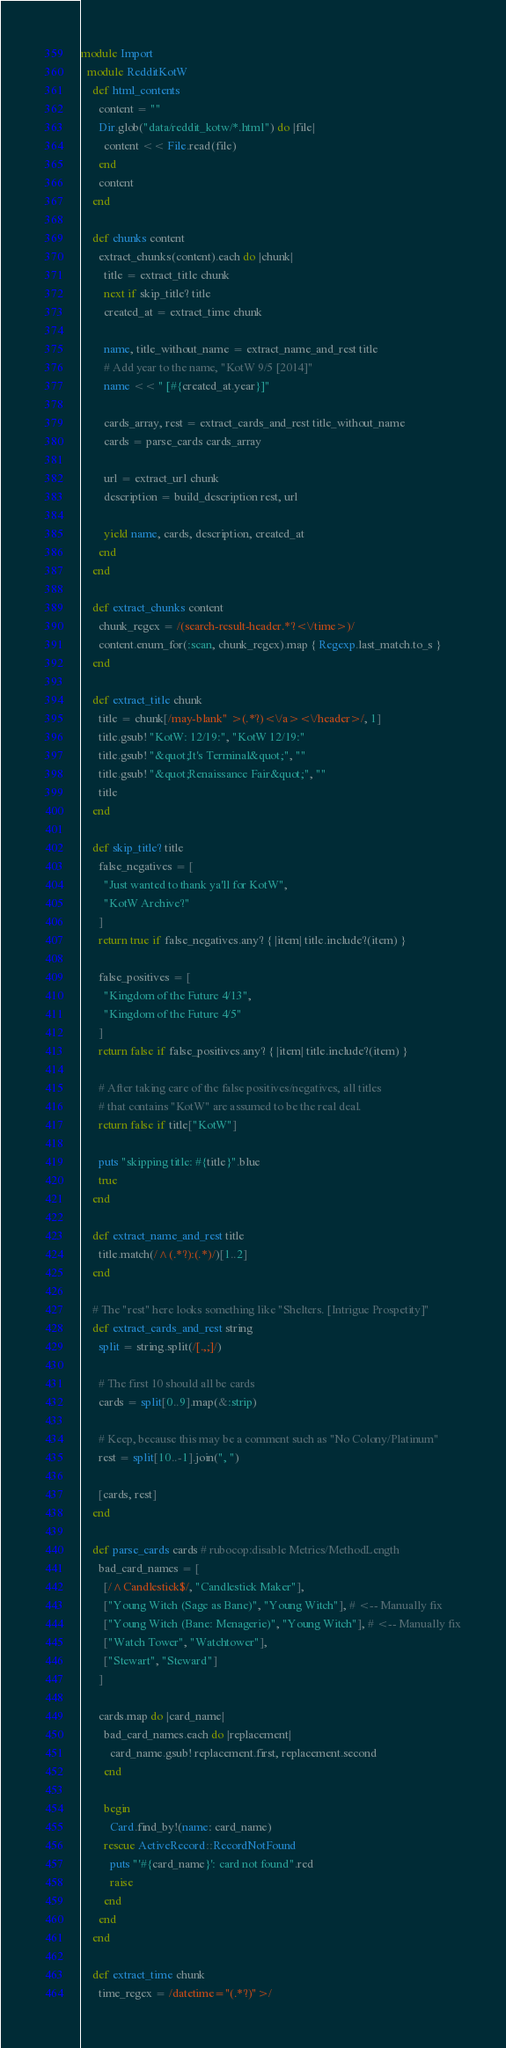Convert code to text. <code><loc_0><loc_0><loc_500><loc_500><_Ruby_>module Import
  module RedditKotW
    def html_contents
      content = ""
      Dir.glob("data/reddit_kotw/*.html") do |file|
        content << File.read(file)
      end
      content
    end

    def chunks content
      extract_chunks(content).each do |chunk|
        title = extract_title chunk
        next if skip_title? title
        created_at = extract_time chunk

        name, title_without_name = extract_name_and_rest title
        # Add year to the name, "KotW 9/5 [2014]"
        name << " [#{created_at.year}]"

        cards_array, rest = extract_cards_and_rest title_without_name
        cards = parse_cards cards_array

        url = extract_url chunk
        description = build_description rest, url

        yield name, cards, description, created_at
      end
    end

    def extract_chunks content
      chunk_regex = /(search-result-header.*?<\/time>)/
      content.enum_for(:scan, chunk_regex).map { Regexp.last_match.to_s }
    end

    def extract_title chunk
      title = chunk[/may-blank" >(.*?)<\/a><\/header>/, 1]
      title.gsub! "KotW: 12/19:", "KotW 12/19:"
      title.gsub! "&quot;It's Terminal&quot;", ""
      title.gsub! "&quot;Renaissance Fair&quot;", ""
      title
    end

    def skip_title? title
      false_negatives = [
        "Just wanted to thank ya'll for KotW",
        "KotW Archive?"
      ]
      return true if false_negatives.any? { |item| title.include?(item) }

      false_positives = [
        "Kingdom of the Future 4/13",
        "Kingdom of the Future 4/5"
      ]
      return false if false_positives.any? { |item| title.include?(item) }

      # After taking care of the false positives/negatives, all titles
      # that contains "KotW" are assumed to be the real deal.
      return false if title["KotW"]

      puts "skipping title: #{title}".blue
      true
    end

    def extract_name_and_rest title
      title.match(/^(.*?):(.*)/)[1..2]
    end

    # The "rest" here looks something like "Shelters. [Intrigue Prospetity]"
    def extract_cards_and_rest string
      split = string.split(/[.,;]/)

      # The first 10 should all be cards
      cards = split[0..9].map(&:strip)

      # Keep, because this may be a comment such as "No Colony/Platinum"
      rest = split[10..-1].join(", ")

      [cards, rest]
    end

    def parse_cards cards # rubocop:disable Metrics/MethodLength
      bad_card_names = [
        [/^Candlestick$/, "Candlestick Maker"],
        ["Young Witch (Sage as Bane)", "Young Witch"], # <-- Manually fix
        ["Young Witch (Bane: Menagerie)", "Young Witch"], # <-- Manually fix
        ["Watch Tower", "Watchtower"],
        ["Stewart", "Steward"]
      ]

      cards.map do |card_name|
        bad_card_names.each do |replacement|
          card_name.gsub! replacement.first, replacement.second
        end

        begin
          Card.find_by!(name: card_name)
        rescue ActiveRecord::RecordNotFound
          puts "'#{card_name}': card not found".red
          raise
        end
      end
    end

    def extract_time chunk
      time_regex = /datetime="(.*?)">/</code> 